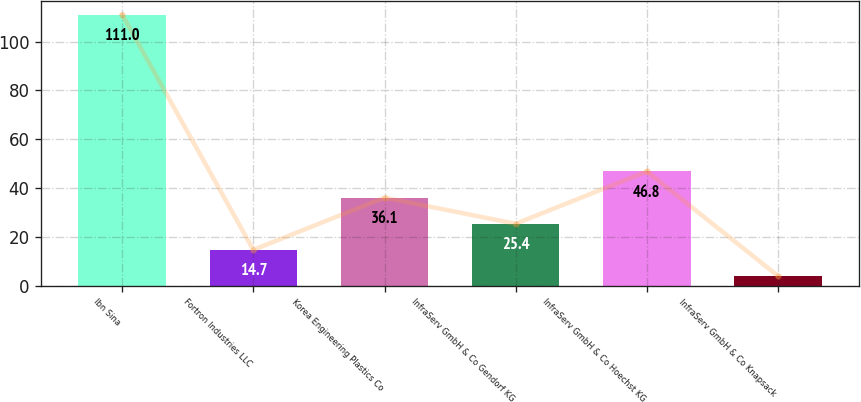Convert chart. <chart><loc_0><loc_0><loc_500><loc_500><bar_chart><fcel>Ibn Sina<fcel>Fortron Industries LLC<fcel>Korea Engineering Plastics Co<fcel>InfraServ GmbH & Co Gendorf KG<fcel>InfraServ GmbH & Co Hoechst KG<fcel>InfraServ GmbH & Co Knapsack<nl><fcel>111<fcel>14.7<fcel>36.1<fcel>25.4<fcel>46.8<fcel>4<nl></chart> 